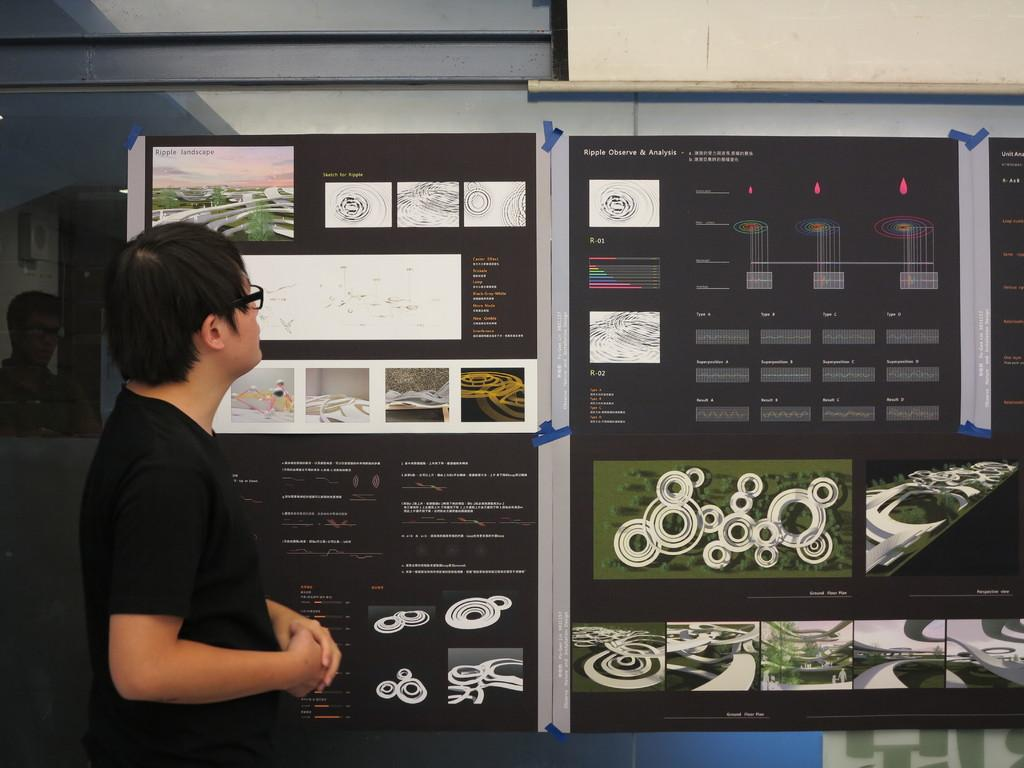What is the main subject of the image? There is a person standing in the image. Can you describe the person's clothing? The person is wearing a black t-shirt. What else can be seen in the image besides the person? There are posters on a board in the image. What type of pollution is visible in the image? There is no visible pollution in the image; it only features a person standing and posters on a board. What kind of pencil is being used to write on the posters? There is no pencil visible in the image, and it is not mentioned that the posters are being written on. 